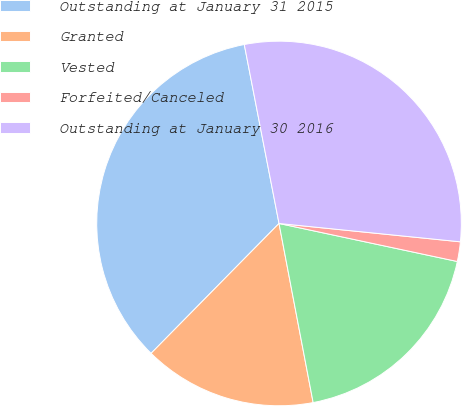Convert chart to OTSL. <chart><loc_0><loc_0><loc_500><loc_500><pie_chart><fcel>Outstanding at January 31 2015<fcel>Granted<fcel>Vested<fcel>Forfeited/Canceled<fcel>Outstanding at January 30 2016<nl><fcel>34.57%<fcel>15.38%<fcel>18.66%<fcel>1.74%<fcel>29.66%<nl></chart> 